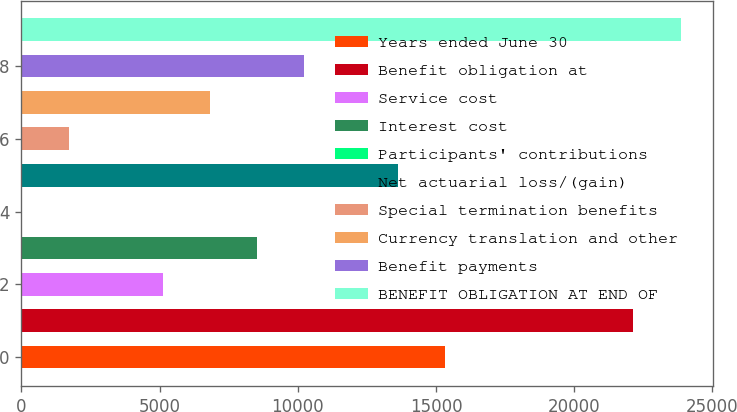Convert chart. <chart><loc_0><loc_0><loc_500><loc_500><bar_chart><fcel>Years ended June 30<fcel>Benefit obligation at<fcel>Service cost<fcel>Interest cost<fcel>Participants' contributions<fcel>Net actuarial loss/(gain)<fcel>Special termination benefits<fcel>Currency translation and other<fcel>Benefit payments<fcel>BENEFIT OBLIGATION AT END OF<nl><fcel>15334.5<fcel>22144.5<fcel>5119.5<fcel>8524.5<fcel>12<fcel>13632<fcel>1714.5<fcel>6822<fcel>10227<fcel>23847<nl></chart> 